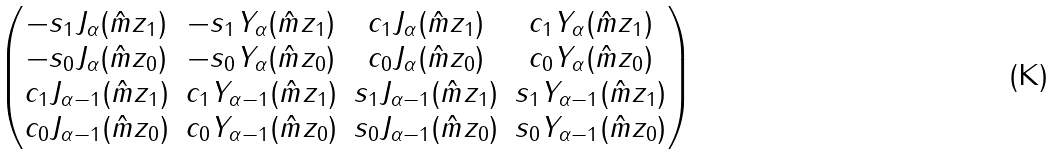<formula> <loc_0><loc_0><loc_500><loc_500>\begin{pmatrix} - s _ { 1 } J _ { \alpha } ( \hat { m } z _ { 1 } ) & - s _ { 1 } Y _ { \alpha } ( \hat { m } z _ { 1 } ) & c _ { 1 } J _ { \alpha } ( \hat { m } z _ { 1 } ) & c _ { 1 } Y _ { \alpha } ( \hat { m } z _ { 1 } ) \\ - s _ { 0 } J _ { \alpha } ( \hat { m } z _ { 0 } ) & - s _ { 0 } Y _ { \alpha } ( \hat { m } z _ { 0 } ) & c _ { 0 } J _ { \alpha } ( \hat { m } z _ { 0 } ) & c _ { 0 } Y _ { \alpha } ( \hat { m } z _ { 0 } ) \\ c _ { 1 } J _ { \alpha - 1 } ( \hat { m } z _ { 1 } ) & c _ { 1 } Y _ { \alpha - 1 } ( \hat { m } z _ { 1 } ) & s _ { 1 } J _ { \alpha - 1 } ( \hat { m } z _ { 1 } ) & s _ { 1 } Y _ { \alpha - 1 } ( \hat { m } z _ { 1 } ) \\ c _ { 0 } J _ { \alpha - 1 } ( \hat { m } z _ { 0 } ) & c _ { 0 } Y _ { \alpha - 1 } ( \hat { m } z _ { 0 } ) & s _ { 0 } J _ { \alpha - 1 } ( \hat { m } z _ { 0 } ) & s _ { 0 } Y _ { \alpha - 1 } ( \hat { m } z _ { 0 } ) \end{pmatrix}</formula> 